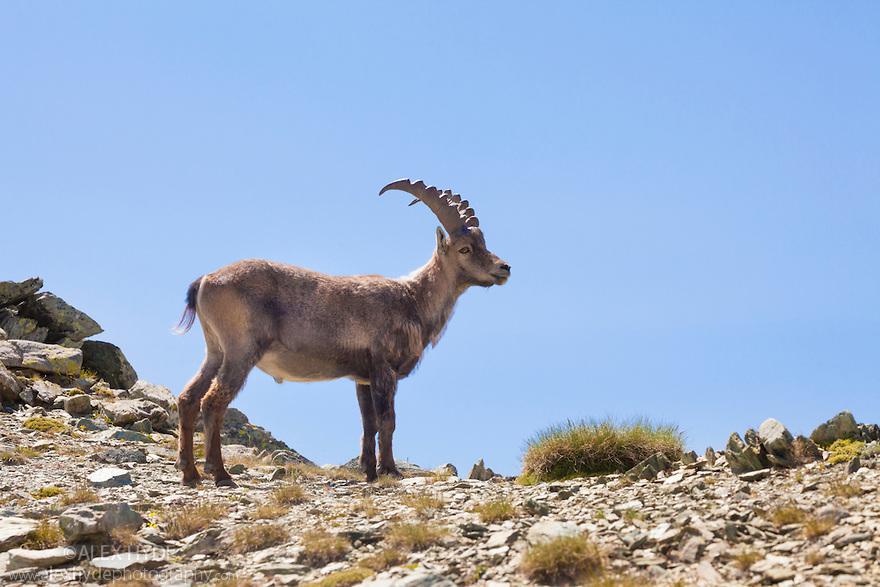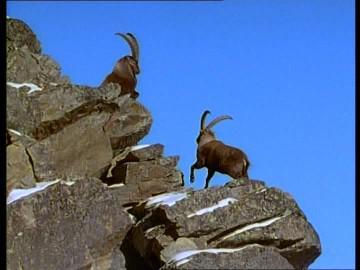The first image is the image on the left, the second image is the image on the right. For the images displayed, is the sentence "There are more rams in the image on the right than in the image on the left." factually correct? Answer yes or no. Yes. The first image is the image on the left, the second image is the image on the right. Evaluate the accuracy of this statement regarding the images: "One image contains one hooved animal with short horns, which is standing on some platform with its body turned leftward.". Is it true? Answer yes or no. No. 